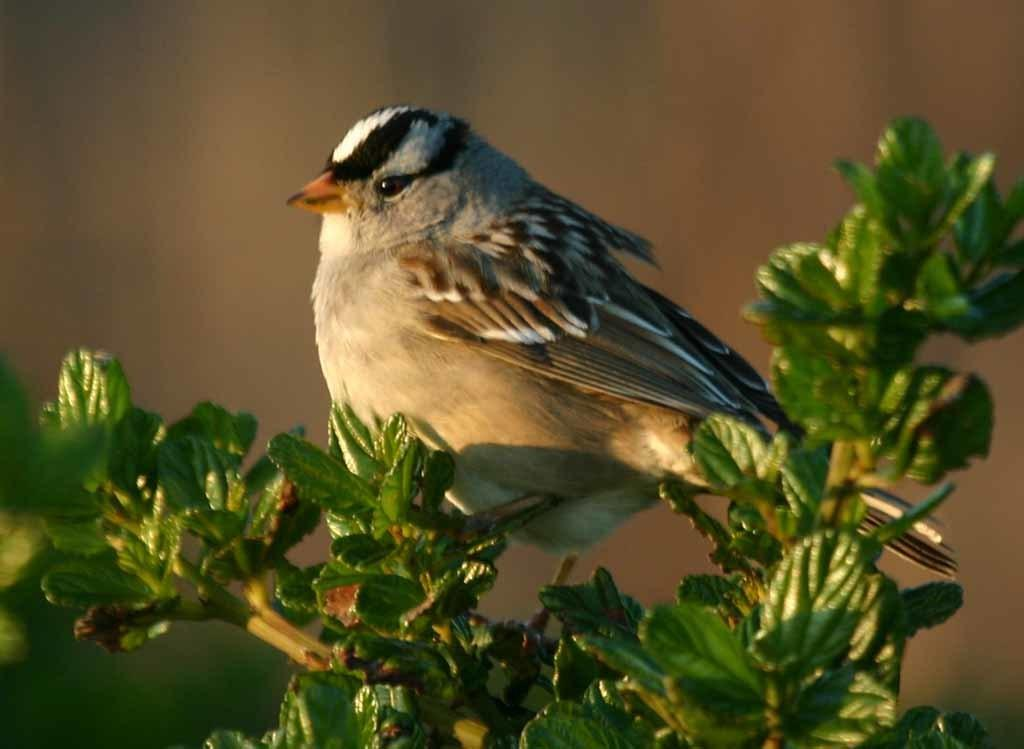What type of animal is standing in the image? There is a bird standing in the image. What other elements can be seen at the bottom of the image? Leaves of a plant are visible at the bottom of the image. Can you describe the background of the image? The background of the image is blurry. What type of pleasure does the bird's brother experience in the image? There is no mention of a brother or pleasure in the image; it only features a bird and leaves of a plant. 